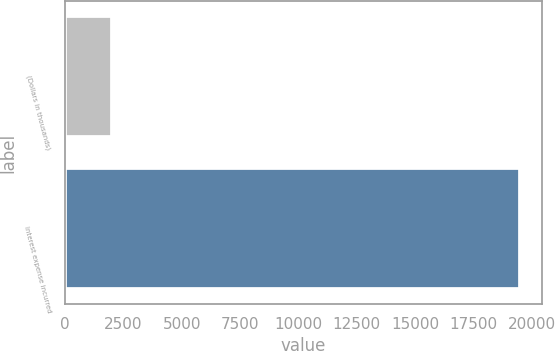<chart> <loc_0><loc_0><loc_500><loc_500><bar_chart><fcel>(Dollars in thousands)<fcel>Interest expense incurred<nl><fcel>2018<fcel>19472<nl></chart> 